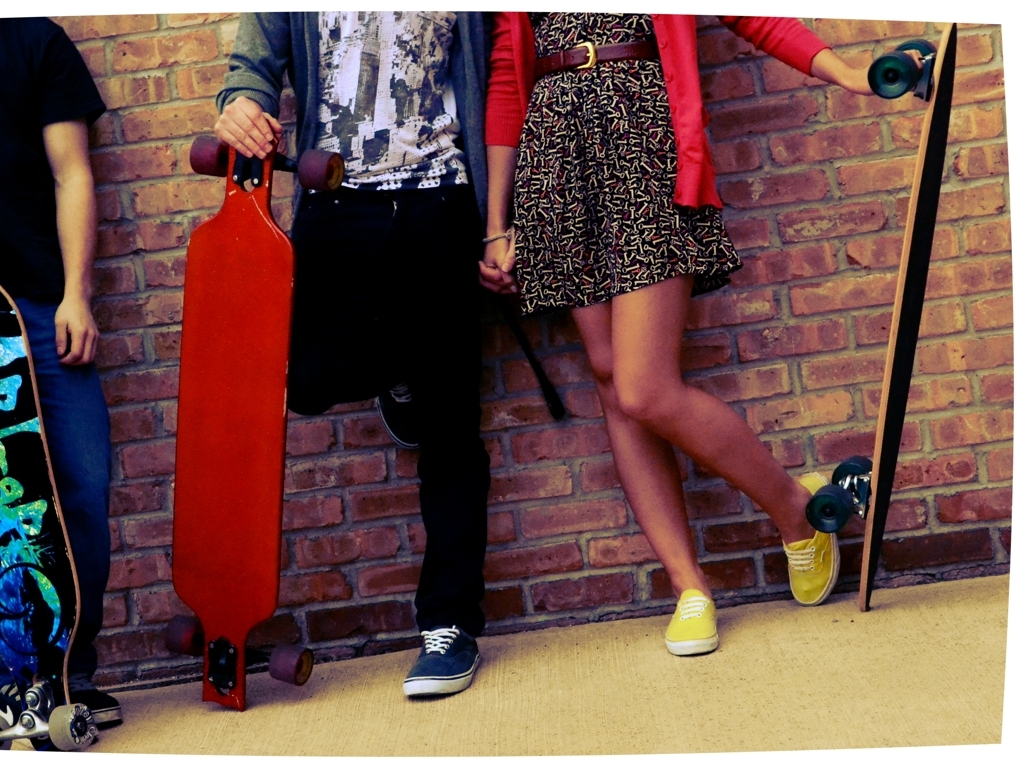Can you describe the atmosphere or setting of this image? The image depicts a casual and urban setting, possibly hinting at a session of skateboarding or longboarding with friends. The presence of multiple boards and the relaxed attire of the individuals suggests a social gathering centered around the sport. The brick wall in the background gives it an industrial or street feel, adding to the overall youth-oriented and recreational theme of the scene. 